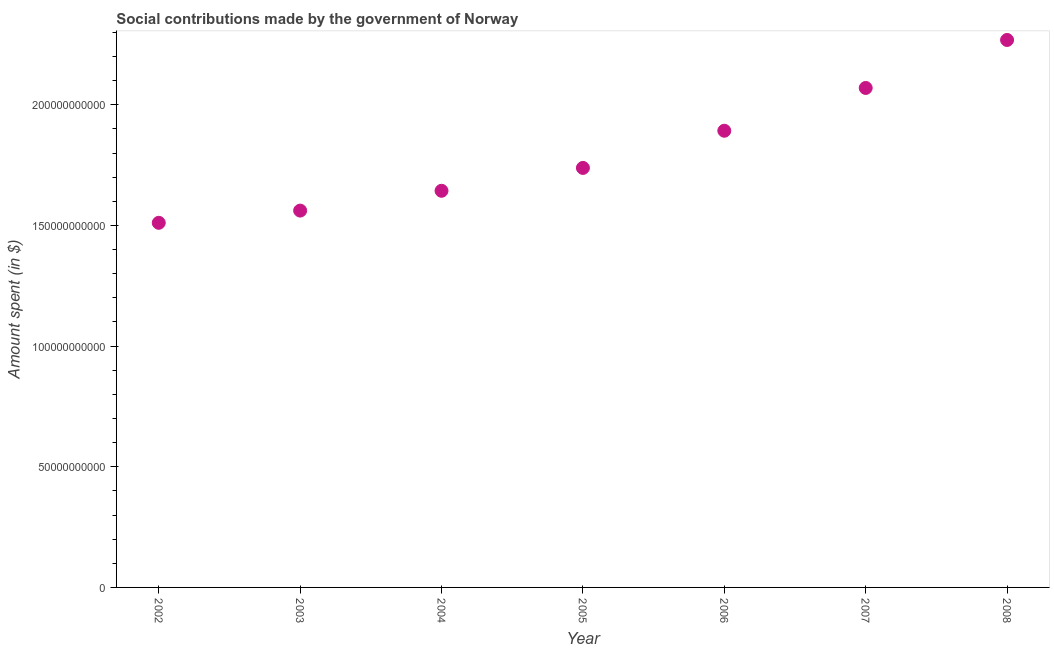What is the amount spent in making social contributions in 2006?
Your answer should be very brief. 1.89e+11. Across all years, what is the maximum amount spent in making social contributions?
Keep it short and to the point. 2.27e+11. Across all years, what is the minimum amount spent in making social contributions?
Keep it short and to the point. 1.51e+11. What is the sum of the amount spent in making social contributions?
Provide a succinct answer. 1.27e+12. What is the difference between the amount spent in making social contributions in 2005 and 2008?
Offer a very short reply. -5.30e+1. What is the average amount spent in making social contributions per year?
Provide a succinct answer. 1.81e+11. What is the median amount spent in making social contributions?
Keep it short and to the point. 1.74e+11. In how many years, is the amount spent in making social contributions greater than 140000000000 $?
Offer a terse response. 7. What is the ratio of the amount spent in making social contributions in 2003 to that in 2006?
Your answer should be very brief. 0.83. Is the amount spent in making social contributions in 2002 less than that in 2003?
Your response must be concise. Yes. What is the difference between the highest and the second highest amount spent in making social contributions?
Ensure brevity in your answer.  1.99e+1. Is the sum of the amount spent in making social contributions in 2006 and 2008 greater than the maximum amount spent in making social contributions across all years?
Your response must be concise. Yes. What is the difference between the highest and the lowest amount spent in making social contributions?
Your answer should be compact. 7.58e+1. How many dotlines are there?
Give a very brief answer. 1. What is the difference between two consecutive major ticks on the Y-axis?
Your response must be concise. 5.00e+1. What is the title of the graph?
Make the answer very short. Social contributions made by the government of Norway. What is the label or title of the X-axis?
Make the answer very short. Year. What is the label or title of the Y-axis?
Ensure brevity in your answer.  Amount spent (in $). What is the Amount spent (in $) in 2002?
Offer a very short reply. 1.51e+11. What is the Amount spent (in $) in 2003?
Give a very brief answer. 1.56e+11. What is the Amount spent (in $) in 2004?
Your answer should be very brief. 1.64e+11. What is the Amount spent (in $) in 2005?
Give a very brief answer. 1.74e+11. What is the Amount spent (in $) in 2006?
Your response must be concise. 1.89e+11. What is the Amount spent (in $) in 2007?
Ensure brevity in your answer.  2.07e+11. What is the Amount spent (in $) in 2008?
Give a very brief answer. 2.27e+11. What is the difference between the Amount spent (in $) in 2002 and 2003?
Give a very brief answer. -5.06e+09. What is the difference between the Amount spent (in $) in 2002 and 2004?
Keep it short and to the point. -1.33e+1. What is the difference between the Amount spent (in $) in 2002 and 2005?
Offer a very short reply. -2.27e+1. What is the difference between the Amount spent (in $) in 2002 and 2006?
Provide a succinct answer. -3.82e+1. What is the difference between the Amount spent (in $) in 2002 and 2007?
Give a very brief answer. -5.59e+1. What is the difference between the Amount spent (in $) in 2002 and 2008?
Offer a very short reply. -7.58e+1. What is the difference between the Amount spent (in $) in 2003 and 2004?
Your response must be concise. -8.21e+09. What is the difference between the Amount spent (in $) in 2003 and 2005?
Your answer should be very brief. -1.77e+1. What is the difference between the Amount spent (in $) in 2003 and 2006?
Keep it short and to the point. -3.31e+1. What is the difference between the Amount spent (in $) in 2003 and 2007?
Provide a succinct answer. -5.08e+1. What is the difference between the Amount spent (in $) in 2003 and 2008?
Offer a very short reply. -7.07e+1. What is the difference between the Amount spent (in $) in 2004 and 2005?
Ensure brevity in your answer.  -9.48e+09. What is the difference between the Amount spent (in $) in 2004 and 2006?
Offer a very short reply. -2.49e+1. What is the difference between the Amount spent (in $) in 2004 and 2007?
Provide a short and direct response. -4.26e+1. What is the difference between the Amount spent (in $) in 2004 and 2008?
Your answer should be very brief. -6.25e+1. What is the difference between the Amount spent (in $) in 2005 and 2006?
Offer a terse response. -1.54e+1. What is the difference between the Amount spent (in $) in 2005 and 2007?
Provide a short and direct response. -3.31e+1. What is the difference between the Amount spent (in $) in 2005 and 2008?
Keep it short and to the point. -5.30e+1. What is the difference between the Amount spent (in $) in 2006 and 2007?
Provide a short and direct response. -1.77e+1. What is the difference between the Amount spent (in $) in 2006 and 2008?
Your answer should be compact. -3.76e+1. What is the difference between the Amount spent (in $) in 2007 and 2008?
Offer a terse response. -1.99e+1. What is the ratio of the Amount spent (in $) in 2002 to that in 2003?
Keep it short and to the point. 0.97. What is the ratio of the Amount spent (in $) in 2002 to that in 2004?
Provide a short and direct response. 0.92. What is the ratio of the Amount spent (in $) in 2002 to that in 2005?
Your answer should be very brief. 0.87. What is the ratio of the Amount spent (in $) in 2002 to that in 2006?
Offer a very short reply. 0.8. What is the ratio of the Amount spent (in $) in 2002 to that in 2007?
Keep it short and to the point. 0.73. What is the ratio of the Amount spent (in $) in 2002 to that in 2008?
Ensure brevity in your answer.  0.67. What is the ratio of the Amount spent (in $) in 2003 to that in 2004?
Ensure brevity in your answer.  0.95. What is the ratio of the Amount spent (in $) in 2003 to that in 2005?
Provide a succinct answer. 0.9. What is the ratio of the Amount spent (in $) in 2003 to that in 2006?
Provide a succinct answer. 0.82. What is the ratio of the Amount spent (in $) in 2003 to that in 2007?
Offer a terse response. 0.75. What is the ratio of the Amount spent (in $) in 2003 to that in 2008?
Offer a terse response. 0.69. What is the ratio of the Amount spent (in $) in 2004 to that in 2005?
Ensure brevity in your answer.  0.94. What is the ratio of the Amount spent (in $) in 2004 to that in 2006?
Your answer should be very brief. 0.87. What is the ratio of the Amount spent (in $) in 2004 to that in 2007?
Your answer should be very brief. 0.79. What is the ratio of the Amount spent (in $) in 2004 to that in 2008?
Ensure brevity in your answer.  0.72. What is the ratio of the Amount spent (in $) in 2005 to that in 2006?
Provide a succinct answer. 0.92. What is the ratio of the Amount spent (in $) in 2005 to that in 2007?
Keep it short and to the point. 0.84. What is the ratio of the Amount spent (in $) in 2005 to that in 2008?
Keep it short and to the point. 0.77. What is the ratio of the Amount spent (in $) in 2006 to that in 2007?
Your response must be concise. 0.91. What is the ratio of the Amount spent (in $) in 2006 to that in 2008?
Make the answer very short. 0.83. What is the ratio of the Amount spent (in $) in 2007 to that in 2008?
Give a very brief answer. 0.91. 